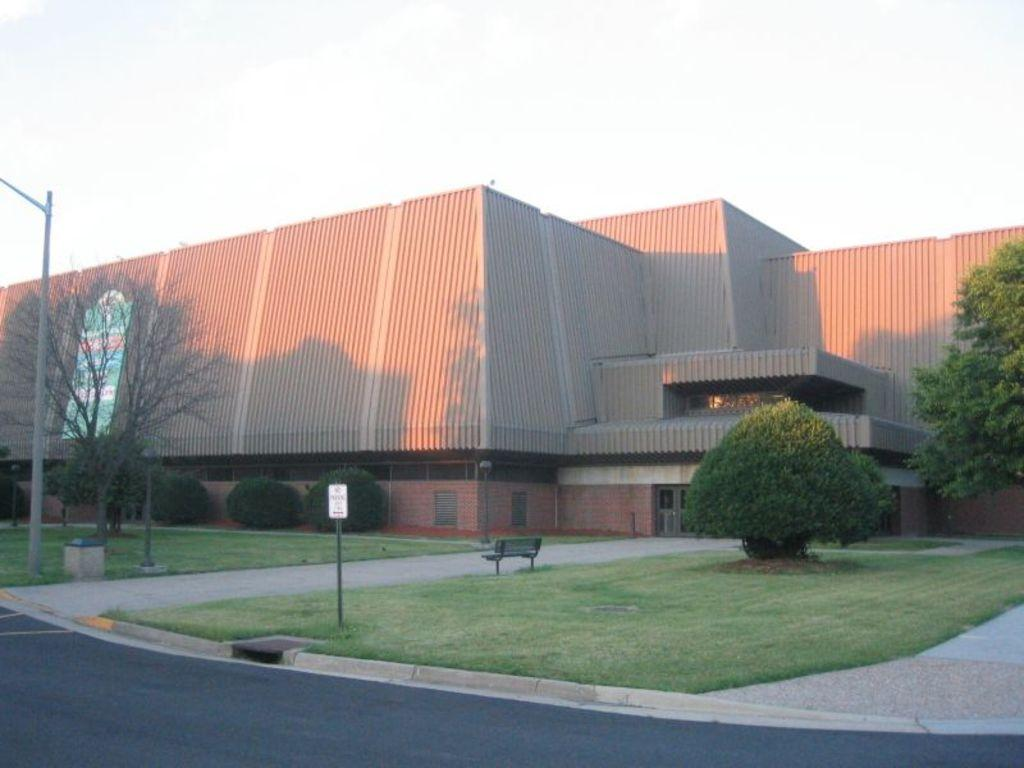What type of structure is present in the image? There is a building in the image. What type of vegetation can be seen in the image? There are trees, plants, and grass visible in the image. What type of seating is available in the image? There is a bench in the image. What type of vertical structure is present in the image? There is a pole in the image. What type of surface is visible in the image? There is a road in the image. What type of signage is present in the image? There is a board in the image. What part of the natural environment is visible in the image? The sky is visible in the image. Can you tell me how many owls are sitting on the bench in the image? There are no owls present in the image; only the bench, building, trees, plants, grass, pole, road, board, and sky are visible. What type of riddle is written on the board in the image? There is no riddle present on the board in the image; only a board is visible. 